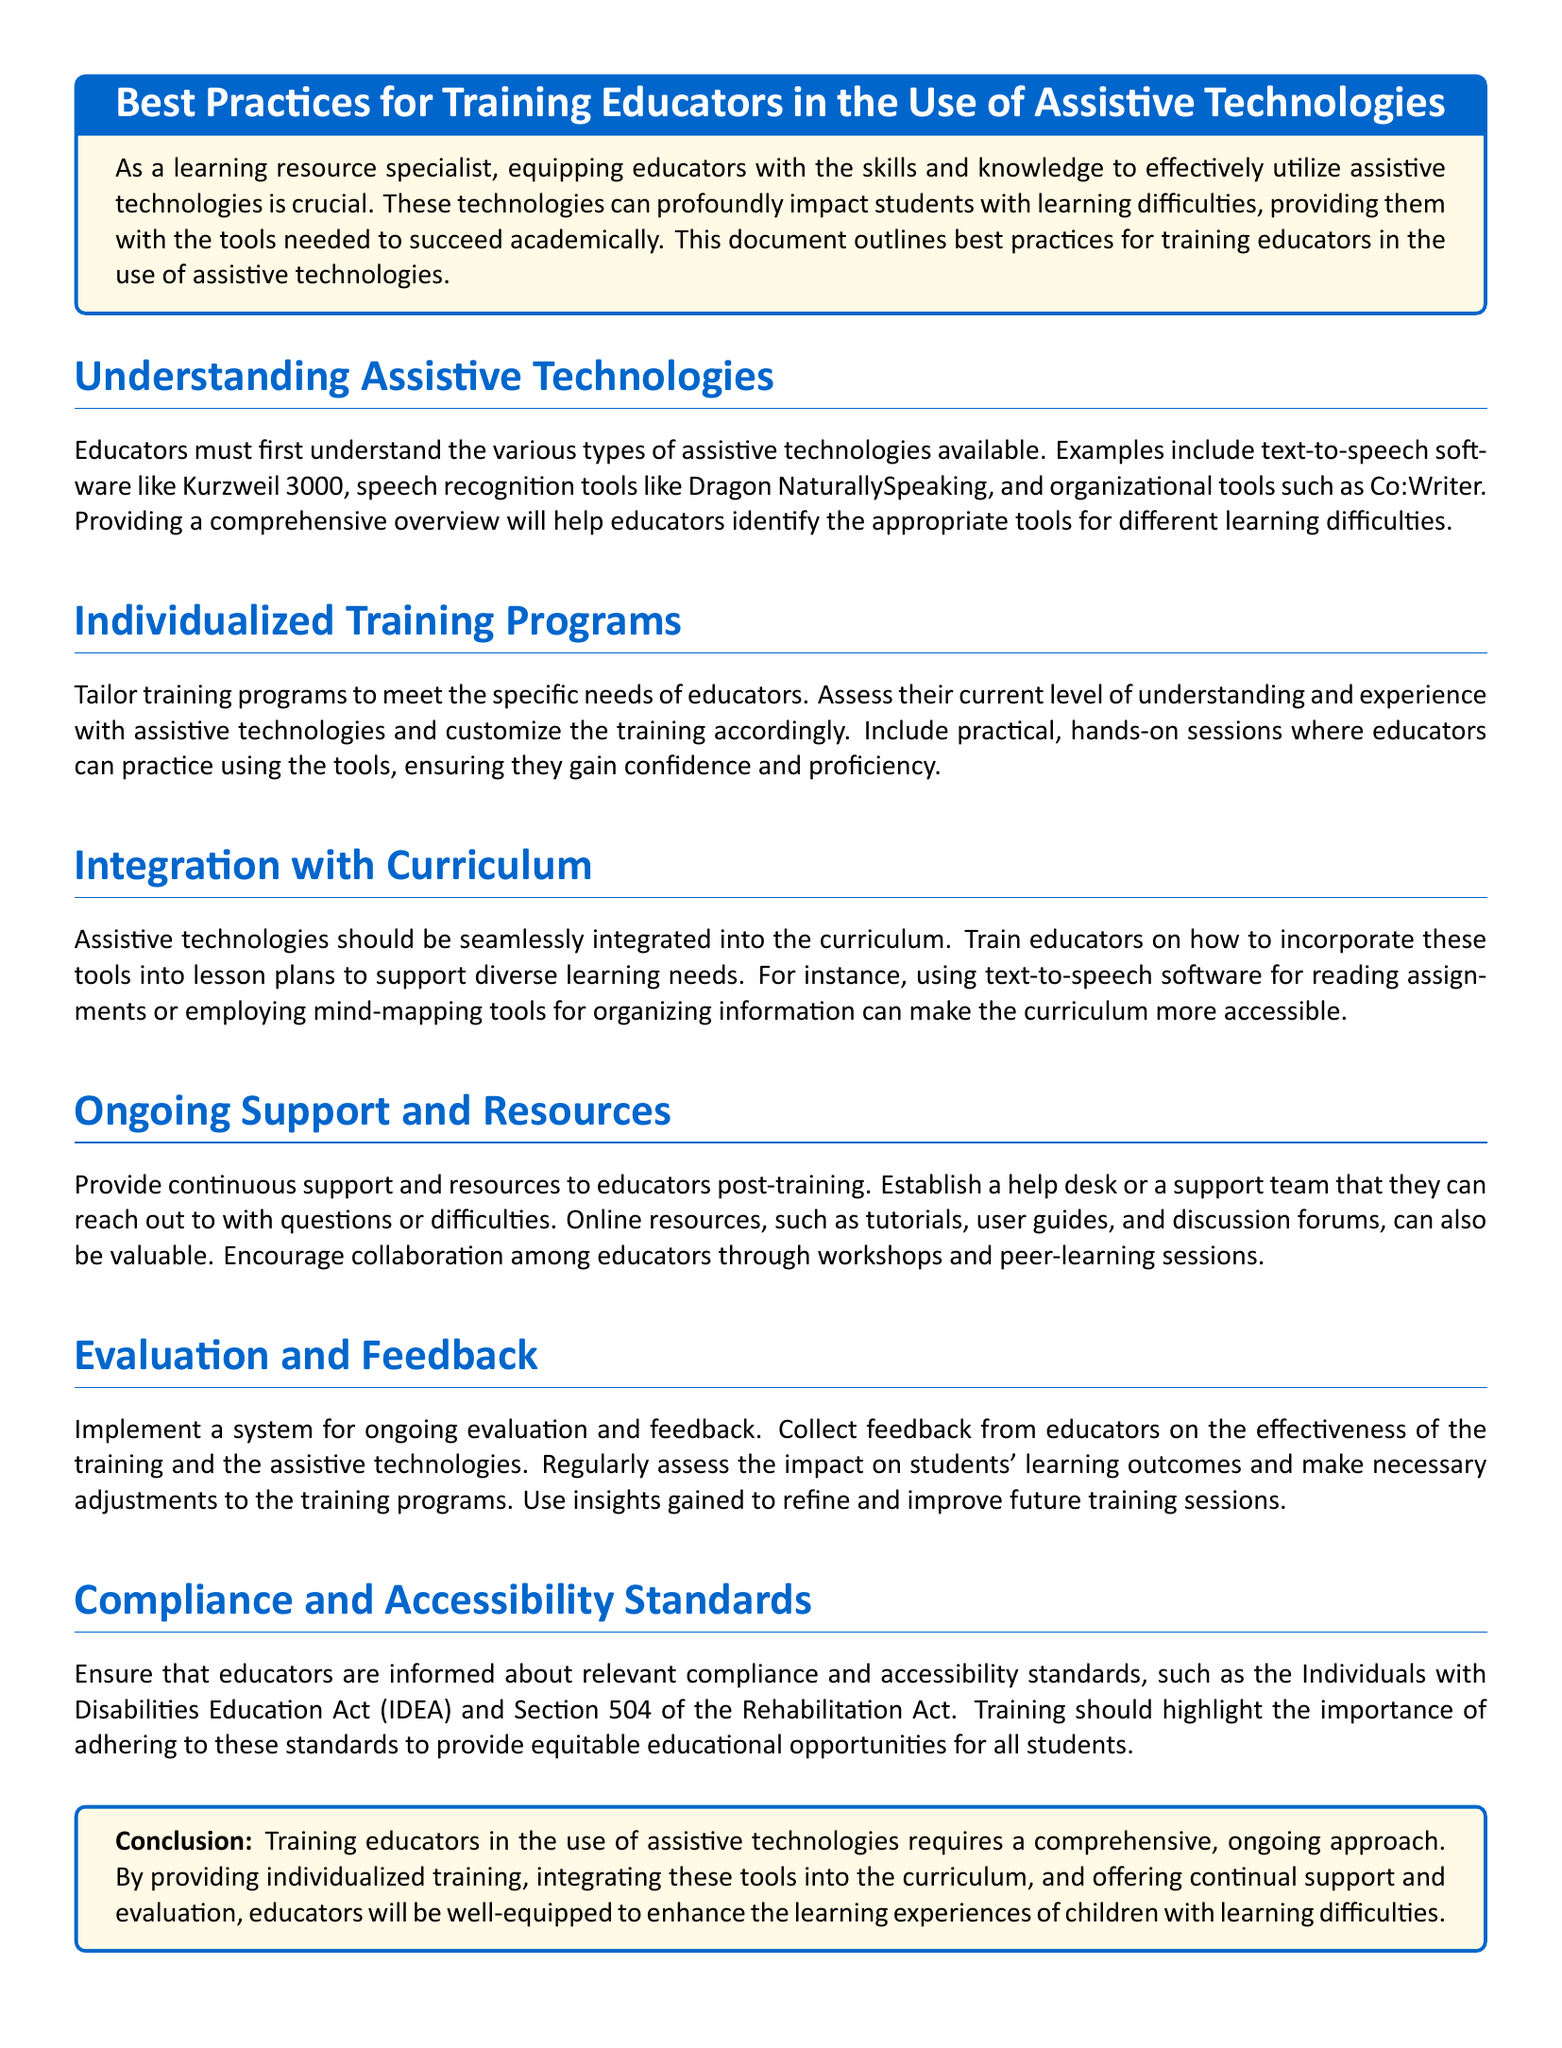What are examples of assistive technologies? The document lists examples like text-to-speech software, speech recognition tools, and organizational tools.
Answer: text-to-speech software, speech recognition tools, organizational tools What should training programs be tailored to? The document states that training programs should be tailored to meet the specific needs of educators, including their understanding and experience.
Answer: specific needs of educators What is one method suggested for integrating assistive technologies? The document suggests using text-to-speech software for reading assignments as a method of integration.
Answer: text-to-speech software for reading assignments What ongoing support is recommended post-training? The document recommends establishing a help desk or support team for ongoing support after training.
Answer: help desk or support team What does the document emphasize regarding evaluation? The document emphasizes implementing a system for ongoing evaluation and feedback regarding training effectiveness and student outcomes.
Answer: ongoing evaluation and feedback What compliance standards should educators be informed about? The document mentions the Individuals with Disabilities Education Act (IDEA) and Section 504 of the Rehabilitation Act as important compliance standards.
Answer: Individuals with Disabilities Education Act (IDEA) and Section 504 of the Rehabilitation Act What type of sessions can encourage collaboration among educators? The document mentions workshops and peer-learning sessions as ways to encourage collaboration.
Answer: workshops and peer-learning sessions What is the conclusion regarding training approaches? The document concludes that a comprehensive, ongoing approach is necessary for training educators effectively.
Answer: comprehensive, ongoing approach 